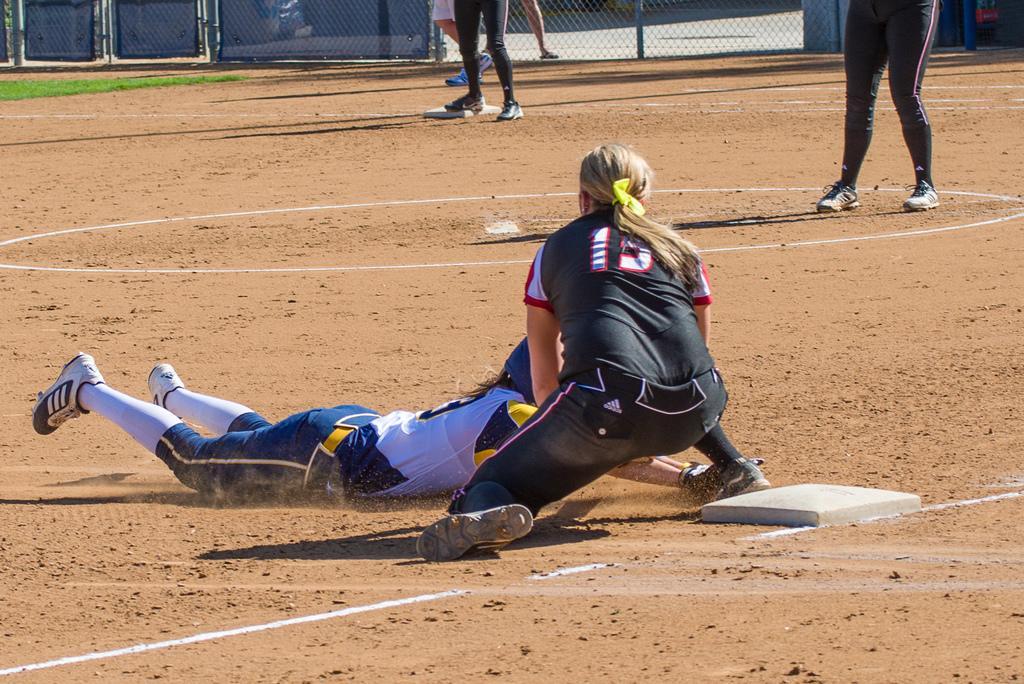In one or two sentences, can you explain what this image depicts? In this image we can see a person is lying on the ground and beside there is another person in motion on the ground. In the background we can legs of few persons and objects on the ground and we can see fence and grass on the ground. 